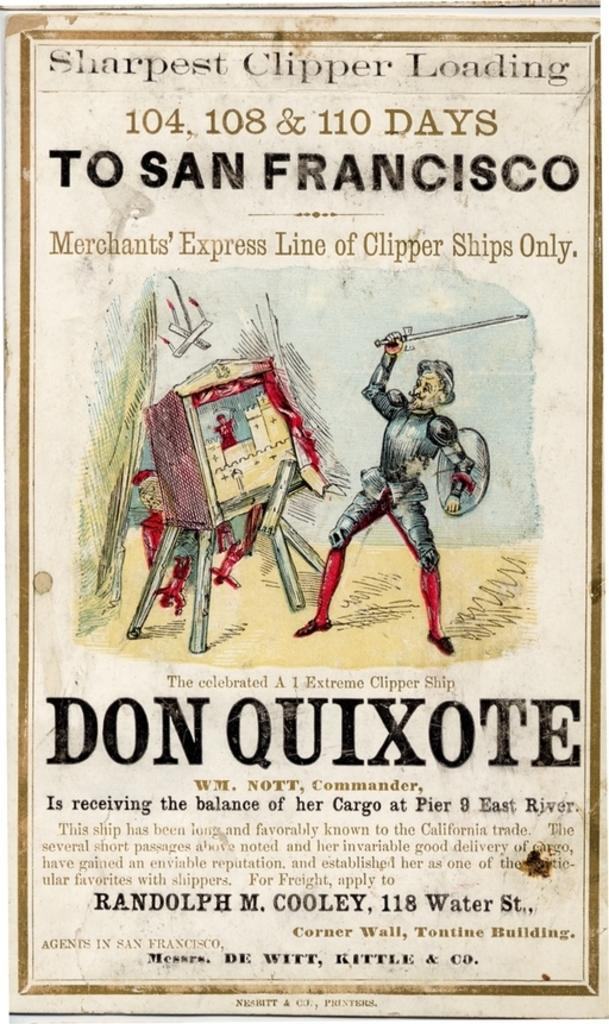Provide a one-sentence caption for the provided image. A poster has a man in armor holding a small sword and it says don quixote under it. 